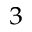Convert formula to latex. <formula><loc_0><loc_0><loc_500><loc_500>_ { 3 }</formula> 